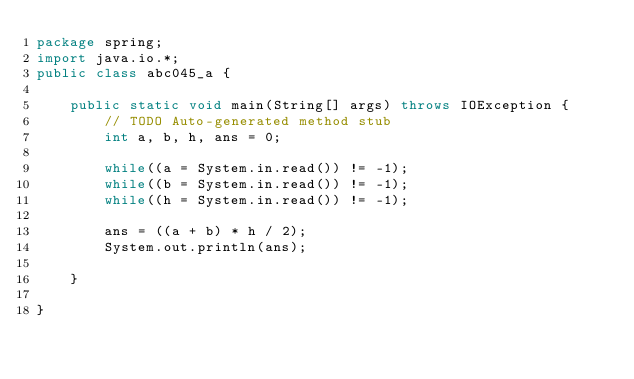<code> <loc_0><loc_0><loc_500><loc_500><_Java_>package spring;
import java.io.*;
public class abc045_a {

	public static void main(String[] args) throws IOException {
		// TODO Auto-generated method stub
		int a, b, h, ans = 0;
		
		while((a = System.in.read()) != -1);
		while((b = System.in.read()) != -1);
		while((h = System.in.read()) != -1);
	
		ans = ((a + b) * h / 2);
		System.out.println(ans);

	}

}
</code> 